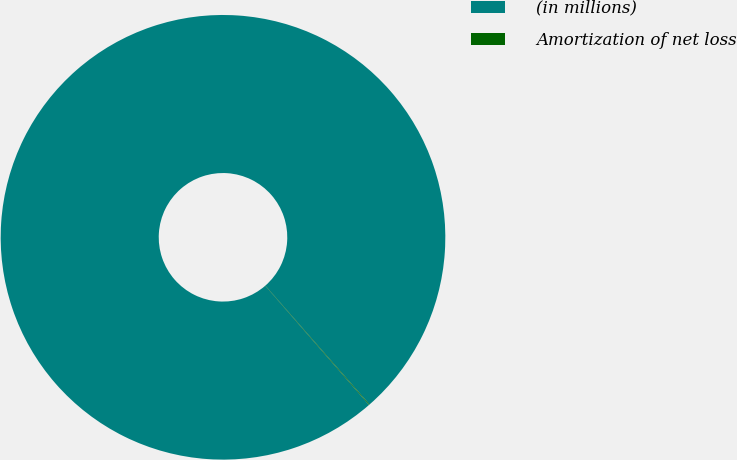Convert chart to OTSL. <chart><loc_0><loc_0><loc_500><loc_500><pie_chart><fcel>(in millions)<fcel>Amortization of net loss<nl><fcel>99.95%<fcel>0.05%<nl></chart> 